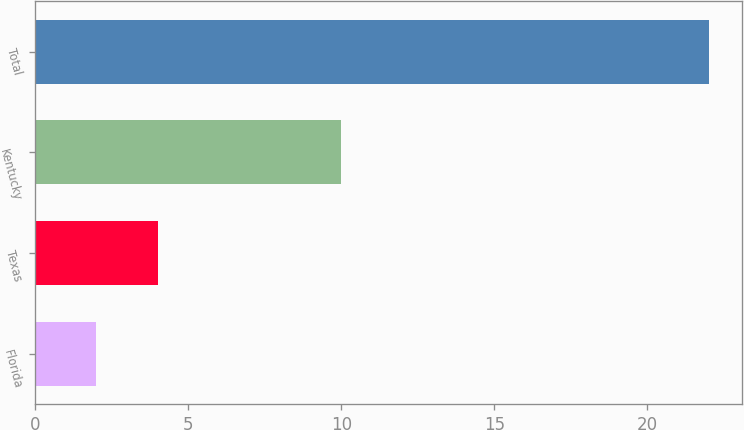<chart> <loc_0><loc_0><loc_500><loc_500><bar_chart><fcel>Florida<fcel>Texas<fcel>Kentucky<fcel>Total<nl><fcel>2<fcel>4<fcel>10<fcel>22<nl></chart> 